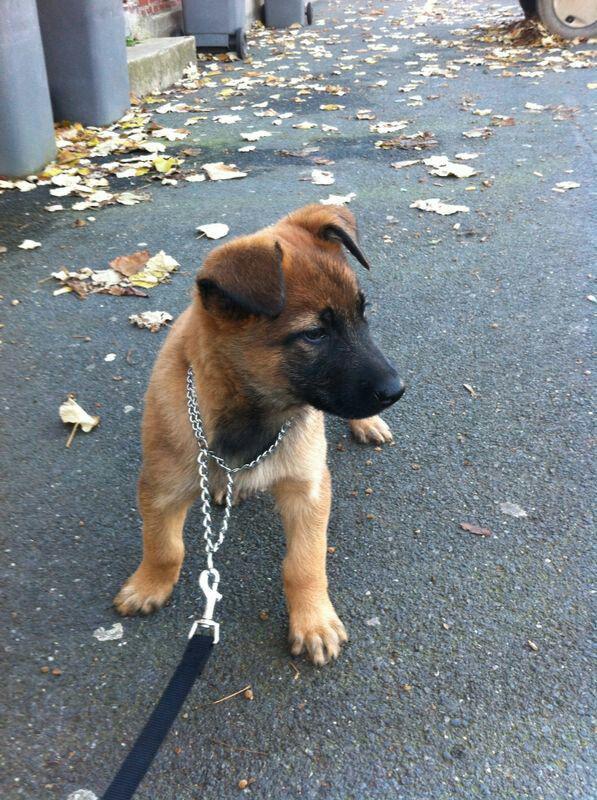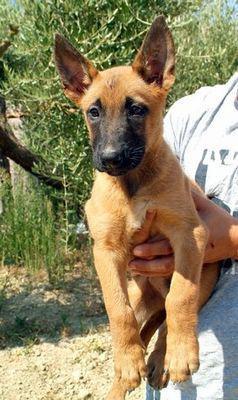The first image is the image on the left, the second image is the image on the right. For the images shown, is this caption "One of the images contains more than one dog." true? Answer yes or no. No. The first image is the image on the left, the second image is the image on the right. Given the left and right images, does the statement "An image shows an arm extending something to a german shepherd on a leash." hold true? Answer yes or no. No. 